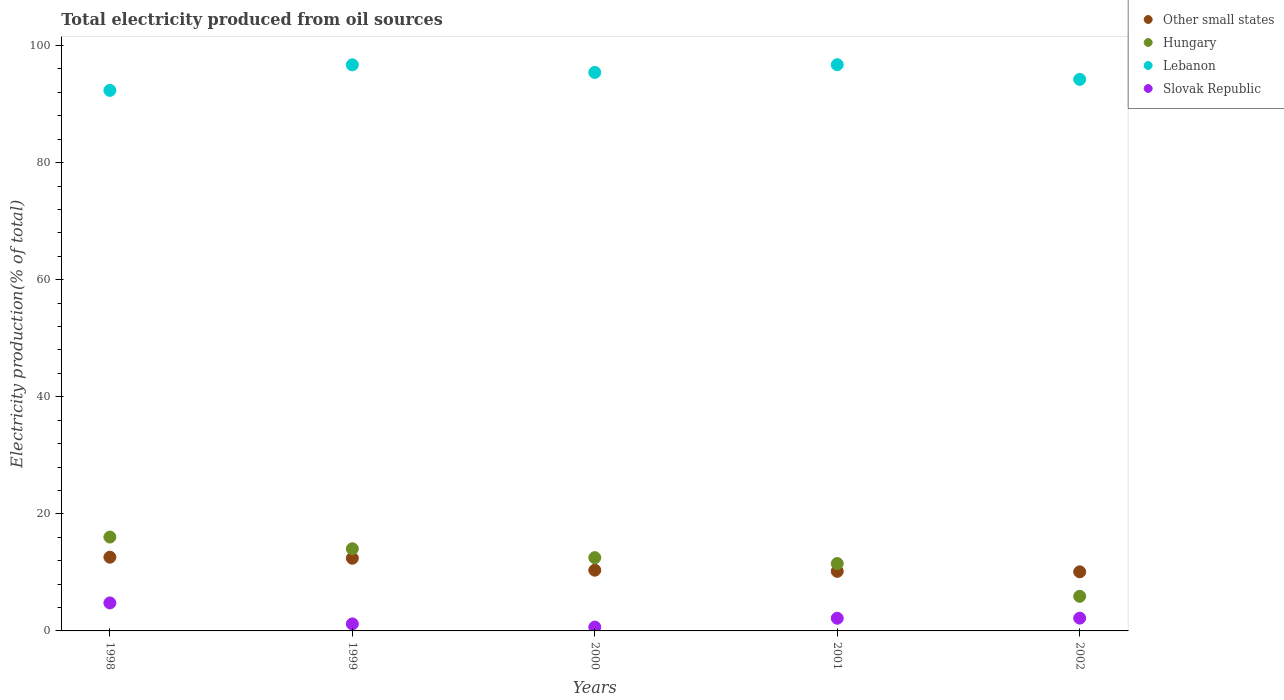Is the number of dotlines equal to the number of legend labels?
Provide a succinct answer. Yes. What is the total electricity produced in Lebanon in 2000?
Ensure brevity in your answer.  95.4. Across all years, what is the maximum total electricity produced in Other small states?
Your response must be concise. 12.6. Across all years, what is the minimum total electricity produced in Other small states?
Your answer should be compact. 10.09. In which year was the total electricity produced in Hungary minimum?
Your answer should be compact. 2002. What is the total total electricity produced in Other small states in the graph?
Offer a very short reply. 55.66. What is the difference between the total electricity produced in Hungary in 2000 and that in 2001?
Give a very brief answer. 1. What is the difference between the total electricity produced in Slovak Republic in 2002 and the total electricity produced in Other small states in 1999?
Your answer should be very brief. -10.23. What is the average total electricity produced in Lebanon per year?
Provide a succinct answer. 95.08. In the year 2002, what is the difference between the total electricity produced in Lebanon and total electricity produced in Slovak Republic?
Give a very brief answer. 92.03. In how many years, is the total electricity produced in Hungary greater than 16 %?
Give a very brief answer. 1. What is the ratio of the total electricity produced in Slovak Republic in 1998 to that in 2002?
Your answer should be very brief. 2.19. Is the total electricity produced in Slovak Republic in 1998 less than that in 1999?
Ensure brevity in your answer.  No. Is the difference between the total electricity produced in Lebanon in 1999 and 2000 greater than the difference between the total electricity produced in Slovak Republic in 1999 and 2000?
Offer a terse response. Yes. What is the difference between the highest and the second highest total electricity produced in Slovak Republic?
Ensure brevity in your answer.  2.6. What is the difference between the highest and the lowest total electricity produced in Other small states?
Provide a succinct answer. 2.5. In how many years, is the total electricity produced in Hungary greater than the average total electricity produced in Hungary taken over all years?
Provide a succinct answer. 3. Is it the case that in every year, the sum of the total electricity produced in Slovak Republic and total electricity produced in Hungary  is greater than the sum of total electricity produced in Other small states and total electricity produced in Lebanon?
Your answer should be compact. Yes. Is it the case that in every year, the sum of the total electricity produced in Lebanon and total electricity produced in Other small states  is greater than the total electricity produced in Slovak Republic?
Make the answer very short. Yes. Is the total electricity produced in Lebanon strictly greater than the total electricity produced in Slovak Republic over the years?
Provide a succinct answer. Yes. What is the difference between two consecutive major ticks on the Y-axis?
Offer a terse response. 20. Are the values on the major ticks of Y-axis written in scientific E-notation?
Your answer should be compact. No. Where does the legend appear in the graph?
Make the answer very short. Top right. What is the title of the graph?
Give a very brief answer. Total electricity produced from oil sources. Does "Cambodia" appear as one of the legend labels in the graph?
Give a very brief answer. No. What is the label or title of the X-axis?
Your response must be concise. Years. What is the label or title of the Y-axis?
Your answer should be compact. Electricity production(% of total). What is the Electricity production(% of total) of Other small states in 1998?
Offer a very short reply. 12.6. What is the Electricity production(% of total) of Hungary in 1998?
Your answer should be compact. 16.03. What is the Electricity production(% of total) in Lebanon in 1998?
Offer a very short reply. 92.34. What is the Electricity production(% of total) in Slovak Republic in 1998?
Offer a very short reply. 4.78. What is the Electricity production(% of total) of Other small states in 1999?
Your answer should be very brief. 12.42. What is the Electricity production(% of total) in Hungary in 1999?
Provide a short and direct response. 14.03. What is the Electricity production(% of total) of Lebanon in 1999?
Offer a terse response. 96.71. What is the Electricity production(% of total) of Slovak Republic in 1999?
Ensure brevity in your answer.  1.2. What is the Electricity production(% of total) of Other small states in 2000?
Ensure brevity in your answer.  10.37. What is the Electricity production(% of total) of Hungary in 2000?
Make the answer very short. 12.51. What is the Electricity production(% of total) of Lebanon in 2000?
Your answer should be compact. 95.4. What is the Electricity production(% of total) of Slovak Republic in 2000?
Give a very brief answer. 0.66. What is the Electricity production(% of total) of Other small states in 2001?
Provide a succinct answer. 10.18. What is the Electricity production(% of total) of Hungary in 2001?
Provide a short and direct response. 11.51. What is the Electricity production(% of total) of Lebanon in 2001?
Give a very brief answer. 96.72. What is the Electricity production(% of total) of Slovak Republic in 2001?
Ensure brevity in your answer.  2.17. What is the Electricity production(% of total) in Other small states in 2002?
Provide a succinct answer. 10.09. What is the Electricity production(% of total) in Hungary in 2002?
Provide a succinct answer. 5.91. What is the Electricity production(% of total) of Lebanon in 2002?
Give a very brief answer. 94.22. What is the Electricity production(% of total) in Slovak Republic in 2002?
Your answer should be compact. 2.19. Across all years, what is the maximum Electricity production(% of total) in Other small states?
Offer a terse response. 12.6. Across all years, what is the maximum Electricity production(% of total) in Hungary?
Your response must be concise. 16.03. Across all years, what is the maximum Electricity production(% of total) in Lebanon?
Your response must be concise. 96.72. Across all years, what is the maximum Electricity production(% of total) in Slovak Republic?
Provide a succinct answer. 4.78. Across all years, what is the minimum Electricity production(% of total) in Other small states?
Offer a terse response. 10.09. Across all years, what is the minimum Electricity production(% of total) of Hungary?
Keep it short and to the point. 5.91. Across all years, what is the minimum Electricity production(% of total) in Lebanon?
Make the answer very short. 92.34. Across all years, what is the minimum Electricity production(% of total) of Slovak Republic?
Your answer should be very brief. 0.66. What is the total Electricity production(% of total) of Other small states in the graph?
Make the answer very short. 55.66. What is the total Electricity production(% of total) of Hungary in the graph?
Your answer should be compact. 60. What is the total Electricity production(% of total) in Lebanon in the graph?
Offer a very short reply. 475.38. What is the total Electricity production(% of total) of Slovak Republic in the graph?
Provide a short and direct response. 10.99. What is the difference between the Electricity production(% of total) in Other small states in 1998 and that in 1999?
Give a very brief answer. 0.18. What is the difference between the Electricity production(% of total) of Hungary in 1998 and that in 1999?
Keep it short and to the point. 2. What is the difference between the Electricity production(% of total) in Lebanon in 1998 and that in 1999?
Offer a terse response. -4.37. What is the difference between the Electricity production(% of total) in Slovak Republic in 1998 and that in 1999?
Keep it short and to the point. 3.58. What is the difference between the Electricity production(% of total) in Other small states in 1998 and that in 2000?
Your answer should be very brief. 2.22. What is the difference between the Electricity production(% of total) in Hungary in 1998 and that in 2000?
Offer a very short reply. 3.52. What is the difference between the Electricity production(% of total) in Lebanon in 1998 and that in 2000?
Make the answer very short. -3.06. What is the difference between the Electricity production(% of total) of Slovak Republic in 1998 and that in 2000?
Keep it short and to the point. 4.13. What is the difference between the Electricity production(% of total) of Other small states in 1998 and that in 2001?
Your answer should be very brief. 2.42. What is the difference between the Electricity production(% of total) in Hungary in 1998 and that in 2001?
Your response must be concise. 4.52. What is the difference between the Electricity production(% of total) of Lebanon in 1998 and that in 2001?
Give a very brief answer. -4.39. What is the difference between the Electricity production(% of total) of Slovak Republic in 1998 and that in 2001?
Keep it short and to the point. 2.62. What is the difference between the Electricity production(% of total) in Other small states in 1998 and that in 2002?
Your answer should be very brief. 2.5. What is the difference between the Electricity production(% of total) of Hungary in 1998 and that in 2002?
Offer a very short reply. 10.12. What is the difference between the Electricity production(% of total) in Lebanon in 1998 and that in 2002?
Ensure brevity in your answer.  -1.88. What is the difference between the Electricity production(% of total) in Slovak Republic in 1998 and that in 2002?
Ensure brevity in your answer.  2.6. What is the difference between the Electricity production(% of total) in Other small states in 1999 and that in 2000?
Provide a succinct answer. 2.04. What is the difference between the Electricity production(% of total) of Hungary in 1999 and that in 2000?
Keep it short and to the point. 1.52. What is the difference between the Electricity production(% of total) of Lebanon in 1999 and that in 2000?
Ensure brevity in your answer.  1.31. What is the difference between the Electricity production(% of total) in Slovak Republic in 1999 and that in 2000?
Make the answer very short. 0.55. What is the difference between the Electricity production(% of total) of Other small states in 1999 and that in 2001?
Provide a short and direct response. 2.24. What is the difference between the Electricity production(% of total) of Hungary in 1999 and that in 2001?
Give a very brief answer. 2.52. What is the difference between the Electricity production(% of total) of Lebanon in 1999 and that in 2001?
Your answer should be very brief. -0.02. What is the difference between the Electricity production(% of total) of Slovak Republic in 1999 and that in 2001?
Give a very brief answer. -0.96. What is the difference between the Electricity production(% of total) of Other small states in 1999 and that in 2002?
Give a very brief answer. 2.32. What is the difference between the Electricity production(% of total) in Hungary in 1999 and that in 2002?
Make the answer very short. 8.12. What is the difference between the Electricity production(% of total) in Lebanon in 1999 and that in 2002?
Provide a succinct answer. 2.49. What is the difference between the Electricity production(% of total) of Slovak Republic in 1999 and that in 2002?
Make the answer very short. -0.98. What is the difference between the Electricity production(% of total) in Other small states in 2000 and that in 2001?
Provide a succinct answer. 0.2. What is the difference between the Electricity production(% of total) in Lebanon in 2000 and that in 2001?
Give a very brief answer. -1.33. What is the difference between the Electricity production(% of total) in Slovak Republic in 2000 and that in 2001?
Keep it short and to the point. -1.51. What is the difference between the Electricity production(% of total) in Other small states in 2000 and that in 2002?
Your response must be concise. 0.28. What is the difference between the Electricity production(% of total) of Hungary in 2000 and that in 2002?
Provide a succinct answer. 6.6. What is the difference between the Electricity production(% of total) of Lebanon in 2000 and that in 2002?
Provide a short and direct response. 1.18. What is the difference between the Electricity production(% of total) of Slovak Republic in 2000 and that in 2002?
Your response must be concise. -1.53. What is the difference between the Electricity production(% of total) in Other small states in 2001 and that in 2002?
Your response must be concise. 0.08. What is the difference between the Electricity production(% of total) of Hungary in 2001 and that in 2002?
Ensure brevity in your answer.  5.6. What is the difference between the Electricity production(% of total) of Lebanon in 2001 and that in 2002?
Offer a terse response. 2.51. What is the difference between the Electricity production(% of total) in Slovak Republic in 2001 and that in 2002?
Provide a succinct answer. -0.02. What is the difference between the Electricity production(% of total) of Other small states in 1998 and the Electricity production(% of total) of Hungary in 1999?
Keep it short and to the point. -1.44. What is the difference between the Electricity production(% of total) of Other small states in 1998 and the Electricity production(% of total) of Lebanon in 1999?
Provide a succinct answer. -84.11. What is the difference between the Electricity production(% of total) of Other small states in 1998 and the Electricity production(% of total) of Slovak Republic in 1999?
Your answer should be compact. 11.39. What is the difference between the Electricity production(% of total) in Hungary in 1998 and the Electricity production(% of total) in Lebanon in 1999?
Provide a short and direct response. -80.67. What is the difference between the Electricity production(% of total) of Hungary in 1998 and the Electricity production(% of total) of Slovak Republic in 1999?
Your answer should be very brief. 14.83. What is the difference between the Electricity production(% of total) of Lebanon in 1998 and the Electricity production(% of total) of Slovak Republic in 1999?
Ensure brevity in your answer.  91.13. What is the difference between the Electricity production(% of total) in Other small states in 1998 and the Electricity production(% of total) in Hungary in 2000?
Offer a very short reply. 0.08. What is the difference between the Electricity production(% of total) of Other small states in 1998 and the Electricity production(% of total) of Lebanon in 2000?
Your response must be concise. -82.8. What is the difference between the Electricity production(% of total) in Other small states in 1998 and the Electricity production(% of total) in Slovak Republic in 2000?
Your answer should be very brief. 11.94. What is the difference between the Electricity production(% of total) in Hungary in 1998 and the Electricity production(% of total) in Lebanon in 2000?
Provide a short and direct response. -79.36. What is the difference between the Electricity production(% of total) of Hungary in 1998 and the Electricity production(% of total) of Slovak Republic in 2000?
Ensure brevity in your answer.  15.38. What is the difference between the Electricity production(% of total) in Lebanon in 1998 and the Electricity production(% of total) in Slovak Republic in 2000?
Your answer should be compact. 91.68. What is the difference between the Electricity production(% of total) in Other small states in 1998 and the Electricity production(% of total) in Hungary in 2001?
Keep it short and to the point. 1.08. What is the difference between the Electricity production(% of total) of Other small states in 1998 and the Electricity production(% of total) of Lebanon in 2001?
Keep it short and to the point. -84.13. What is the difference between the Electricity production(% of total) of Other small states in 1998 and the Electricity production(% of total) of Slovak Republic in 2001?
Keep it short and to the point. 10.43. What is the difference between the Electricity production(% of total) in Hungary in 1998 and the Electricity production(% of total) in Lebanon in 2001?
Keep it short and to the point. -80.69. What is the difference between the Electricity production(% of total) of Hungary in 1998 and the Electricity production(% of total) of Slovak Republic in 2001?
Give a very brief answer. 13.87. What is the difference between the Electricity production(% of total) in Lebanon in 1998 and the Electricity production(% of total) in Slovak Republic in 2001?
Your response must be concise. 90.17. What is the difference between the Electricity production(% of total) in Other small states in 1998 and the Electricity production(% of total) in Hungary in 2002?
Keep it short and to the point. 6.69. What is the difference between the Electricity production(% of total) in Other small states in 1998 and the Electricity production(% of total) in Lebanon in 2002?
Offer a very short reply. -81.62. What is the difference between the Electricity production(% of total) of Other small states in 1998 and the Electricity production(% of total) of Slovak Republic in 2002?
Offer a very short reply. 10.41. What is the difference between the Electricity production(% of total) of Hungary in 1998 and the Electricity production(% of total) of Lebanon in 2002?
Offer a terse response. -78.18. What is the difference between the Electricity production(% of total) of Hungary in 1998 and the Electricity production(% of total) of Slovak Republic in 2002?
Your response must be concise. 13.85. What is the difference between the Electricity production(% of total) of Lebanon in 1998 and the Electricity production(% of total) of Slovak Republic in 2002?
Your answer should be very brief. 90.15. What is the difference between the Electricity production(% of total) of Other small states in 1999 and the Electricity production(% of total) of Hungary in 2000?
Give a very brief answer. -0.1. What is the difference between the Electricity production(% of total) in Other small states in 1999 and the Electricity production(% of total) in Lebanon in 2000?
Your answer should be compact. -82.98. What is the difference between the Electricity production(% of total) in Other small states in 1999 and the Electricity production(% of total) in Slovak Republic in 2000?
Your response must be concise. 11.76. What is the difference between the Electricity production(% of total) in Hungary in 1999 and the Electricity production(% of total) in Lebanon in 2000?
Your response must be concise. -81.37. What is the difference between the Electricity production(% of total) of Hungary in 1999 and the Electricity production(% of total) of Slovak Republic in 2000?
Provide a short and direct response. 13.38. What is the difference between the Electricity production(% of total) in Lebanon in 1999 and the Electricity production(% of total) in Slovak Republic in 2000?
Provide a short and direct response. 96.05. What is the difference between the Electricity production(% of total) of Other small states in 1999 and the Electricity production(% of total) of Hungary in 2001?
Provide a succinct answer. 0.91. What is the difference between the Electricity production(% of total) of Other small states in 1999 and the Electricity production(% of total) of Lebanon in 2001?
Your response must be concise. -84.31. What is the difference between the Electricity production(% of total) in Other small states in 1999 and the Electricity production(% of total) in Slovak Republic in 2001?
Make the answer very short. 10.25. What is the difference between the Electricity production(% of total) of Hungary in 1999 and the Electricity production(% of total) of Lebanon in 2001?
Your answer should be compact. -82.69. What is the difference between the Electricity production(% of total) in Hungary in 1999 and the Electricity production(% of total) in Slovak Republic in 2001?
Keep it short and to the point. 11.87. What is the difference between the Electricity production(% of total) of Lebanon in 1999 and the Electricity production(% of total) of Slovak Republic in 2001?
Your answer should be very brief. 94.54. What is the difference between the Electricity production(% of total) of Other small states in 1999 and the Electricity production(% of total) of Hungary in 2002?
Keep it short and to the point. 6.51. What is the difference between the Electricity production(% of total) of Other small states in 1999 and the Electricity production(% of total) of Lebanon in 2002?
Your answer should be very brief. -81.8. What is the difference between the Electricity production(% of total) of Other small states in 1999 and the Electricity production(% of total) of Slovak Republic in 2002?
Give a very brief answer. 10.23. What is the difference between the Electricity production(% of total) of Hungary in 1999 and the Electricity production(% of total) of Lebanon in 2002?
Provide a succinct answer. -80.18. What is the difference between the Electricity production(% of total) in Hungary in 1999 and the Electricity production(% of total) in Slovak Republic in 2002?
Give a very brief answer. 11.85. What is the difference between the Electricity production(% of total) in Lebanon in 1999 and the Electricity production(% of total) in Slovak Republic in 2002?
Your answer should be very brief. 94.52. What is the difference between the Electricity production(% of total) in Other small states in 2000 and the Electricity production(% of total) in Hungary in 2001?
Offer a very short reply. -1.14. What is the difference between the Electricity production(% of total) of Other small states in 2000 and the Electricity production(% of total) of Lebanon in 2001?
Give a very brief answer. -86.35. What is the difference between the Electricity production(% of total) in Other small states in 2000 and the Electricity production(% of total) in Slovak Republic in 2001?
Offer a terse response. 8.21. What is the difference between the Electricity production(% of total) of Hungary in 2000 and the Electricity production(% of total) of Lebanon in 2001?
Your answer should be compact. -84.21. What is the difference between the Electricity production(% of total) in Hungary in 2000 and the Electricity production(% of total) in Slovak Republic in 2001?
Offer a terse response. 10.35. What is the difference between the Electricity production(% of total) of Lebanon in 2000 and the Electricity production(% of total) of Slovak Republic in 2001?
Ensure brevity in your answer.  93.23. What is the difference between the Electricity production(% of total) of Other small states in 2000 and the Electricity production(% of total) of Hungary in 2002?
Provide a succinct answer. 4.46. What is the difference between the Electricity production(% of total) of Other small states in 2000 and the Electricity production(% of total) of Lebanon in 2002?
Keep it short and to the point. -83.84. What is the difference between the Electricity production(% of total) in Other small states in 2000 and the Electricity production(% of total) in Slovak Republic in 2002?
Your answer should be very brief. 8.19. What is the difference between the Electricity production(% of total) in Hungary in 2000 and the Electricity production(% of total) in Lebanon in 2002?
Keep it short and to the point. -81.7. What is the difference between the Electricity production(% of total) in Hungary in 2000 and the Electricity production(% of total) in Slovak Republic in 2002?
Ensure brevity in your answer.  10.33. What is the difference between the Electricity production(% of total) of Lebanon in 2000 and the Electricity production(% of total) of Slovak Republic in 2002?
Your answer should be compact. 93.21. What is the difference between the Electricity production(% of total) of Other small states in 2001 and the Electricity production(% of total) of Hungary in 2002?
Provide a succinct answer. 4.27. What is the difference between the Electricity production(% of total) of Other small states in 2001 and the Electricity production(% of total) of Lebanon in 2002?
Provide a short and direct response. -84.04. What is the difference between the Electricity production(% of total) of Other small states in 2001 and the Electricity production(% of total) of Slovak Republic in 2002?
Give a very brief answer. 7.99. What is the difference between the Electricity production(% of total) in Hungary in 2001 and the Electricity production(% of total) in Lebanon in 2002?
Keep it short and to the point. -82.7. What is the difference between the Electricity production(% of total) in Hungary in 2001 and the Electricity production(% of total) in Slovak Republic in 2002?
Provide a short and direct response. 9.33. What is the difference between the Electricity production(% of total) of Lebanon in 2001 and the Electricity production(% of total) of Slovak Republic in 2002?
Give a very brief answer. 94.54. What is the average Electricity production(% of total) of Other small states per year?
Offer a very short reply. 11.13. What is the average Electricity production(% of total) in Hungary per year?
Ensure brevity in your answer.  12. What is the average Electricity production(% of total) in Lebanon per year?
Ensure brevity in your answer.  95.08. What is the average Electricity production(% of total) in Slovak Republic per year?
Your response must be concise. 2.2. In the year 1998, what is the difference between the Electricity production(% of total) of Other small states and Electricity production(% of total) of Hungary?
Your response must be concise. -3.44. In the year 1998, what is the difference between the Electricity production(% of total) of Other small states and Electricity production(% of total) of Lebanon?
Ensure brevity in your answer.  -79.74. In the year 1998, what is the difference between the Electricity production(% of total) in Other small states and Electricity production(% of total) in Slovak Republic?
Ensure brevity in your answer.  7.81. In the year 1998, what is the difference between the Electricity production(% of total) of Hungary and Electricity production(% of total) of Lebanon?
Provide a short and direct response. -76.3. In the year 1998, what is the difference between the Electricity production(% of total) in Hungary and Electricity production(% of total) in Slovak Republic?
Your response must be concise. 11.25. In the year 1998, what is the difference between the Electricity production(% of total) of Lebanon and Electricity production(% of total) of Slovak Republic?
Keep it short and to the point. 87.55. In the year 1999, what is the difference between the Electricity production(% of total) in Other small states and Electricity production(% of total) in Hungary?
Provide a succinct answer. -1.62. In the year 1999, what is the difference between the Electricity production(% of total) of Other small states and Electricity production(% of total) of Lebanon?
Your response must be concise. -84.29. In the year 1999, what is the difference between the Electricity production(% of total) in Other small states and Electricity production(% of total) in Slovak Republic?
Provide a succinct answer. 11.21. In the year 1999, what is the difference between the Electricity production(% of total) of Hungary and Electricity production(% of total) of Lebanon?
Make the answer very short. -82.67. In the year 1999, what is the difference between the Electricity production(% of total) of Hungary and Electricity production(% of total) of Slovak Republic?
Provide a short and direct response. 12.83. In the year 1999, what is the difference between the Electricity production(% of total) in Lebanon and Electricity production(% of total) in Slovak Republic?
Provide a short and direct response. 95.5. In the year 2000, what is the difference between the Electricity production(% of total) in Other small states and Electricity production(% of total) in Hungary?
Ensure brevity in your answer.  -2.14. In the year 2000, what is the difference between the Electricity production(% of total) of Other small states and Electricity production(% of total) of Lebanon?
Your response must be concise. -85.02. In the year 2000, what is the difference between the Electricity production(% of total) in Other small states and Electricity production(% of total) in Slovak Republic?
Give a very brief answer. 9.72. In the year 2000, what is the difference between the Electricity production(% of total) in Hungary and Electricity production(% of total) in Lebanon?
Your response must be concise. -82.88. In the year 2000, what is the difference between the Electricity production(% of total) of Hungary and Electricity production(% of total) of Slovak Republic?
Provide a succinct answer. 11.86. In the year 2000, what is the difference between the Electricity production(% of total) in Lebanon and Electricity production(% of total) in Slovak Republic?
Provide a succinct answer. 94.74. In the year 2001, what is the difference between the Electricity production(% of total) in Other small states and Electricity production(% of total) in Hungary?
Make the answer very short. -1.34. In the year 2001, what is the difference between the Electricity production(% of total) in Other small states and Electricity production(% of total) in Lebanon?
Keep it short and to the point. -86.55. In the year 2001, what is the difference between the Electricity production(% of total) of Other small states and Electricity production(% of total) of Slovak Republic?
Offer a very short reply. 8.01. In the year 2001, what is the difference between the Electricity production(% of total) in Hungary and Electricity production(% of total) in Lebanon?
Your response must be concise. -85.21. In the year 2001, what is the difference between the Electricity production(% of total) in Hungary and Electricity production(% of total) in Slovak Republic?
Make the answer very short. 9.35. In the year 2001, what is the difference between the Electricity production(% of total) in Lebanon and Electricity production(% of total) in Slovak Republic?
Your answer should be compact. 94.56. In the year 2002, what is the difference between the Electricity production(% of total) of Other small states and Electricity production(% of total) of Hungary?
Your response must be concise. 4.18. In the year 2002, what is the difference between the Electricity production(% of total) of Other small states and Electricity production(% of total) of Lebanon?
Your answer should be compact. -84.12. In the year 2002, what is the difference between the Electricity production(% of total) in Other small states and Electricity production(% of total) in Slovak Republic?
Offer a terse response. 7.91. In the year 2002, what is the difference between the Electricity production(% of total) of Hungary and Electricity production(% of total) of Lebanon?
Your answer should be compact. -88.31. In the year 2002, what is the difference between the Electricity production(% of total) of Hungary and Electricity production(% of total) of Slovak Republic?
Ensure brevity in your answer.  3.72. In the year 2002, what is the difference between the Electricity production(% of total) in Lebanon and Electricity production(% of total) in Slovak Republic?
Your answer should be compact. 92.03. What is the ratio of the Electricity production(% of total) of Other small states in 1998 to that in 1999?
Your answer should be compact. 1.01. What is the ratio of the Electricity production(% of total) of Hungary in 1998 to that in 1999?
Your answer should be compact. 1.14. What is the ratio of the Electricity production(% of total) in Lebanon in 1998 to that in 1999?
Your response must be concise. 0.95. What is the ratio of the Electricity production(% of total) in Slovak Republic in 1998 to that in 1999?
Offer a very short reply. 3.98. What is the ratio of the Electricity production(% of total) of Other small states in 1998 to that in 2000?
Provide a succinct answer. 1.21. What is the ratio of the Electricity production(% of total) in Hungary in 1998 to that in 2000?
Provide a short and direct response. 1.28. What is the ratio of the Electricity production(% of total) in Lebanon in 1998 to that in 2000?
Ensure brevity in your answer.  0.97. What is the ratio of the Electricity production(% of total) in Slovak Republic in 1998 to that in 2000?
Give a very brief answer. 7.29. What is the ratio of the Electricity production(% of total) in Other small states in 1998 to that in 2001?
Give a very brief answer. 1.24. What is the ratio of the Electricity production(% of total) in Hungary in 1998 to that in 2001?
Provide a succinct answer. 1.39. What is the ratio of the Electricity production(% of total) in Lebanon in 1998 to that in 2001?
Give a very brief answer. 0.95. What is the ratio of the Electricity production(% of total) in Slovak Republic in 1998 to that in 2001?
Your response must be concise. 2.21. What is the ratio of the Electricity production(% of total) of Other small states in 1998 to that in 2002?
Your answer should be compact. 1.25. What is the ratio of the Electricity production(% of total) of Hungary in 1998 to that in 2002?
Make the answer very short. 2.71. What is the ratio of the Electricity production(% of total) in Lebanon in 1998 to that in 2002?
Your response must be concise. 0.98. What is the ratio of the Electricity production(% of total) of Slovak Republic in 1998 to that in 2002?
Keep it short and to the point. 2.19. What is the ratio of the Electricity production(% of total) of Other small states in 1999 to that in 2000?
Your answer should be compact. 1.2. What is the ratio of the Electricity production(% of total) in Hungary in 1999 to that in 2000?
Make the answer very short. 1.12. What is the ratio of the Electricity production(% of total) of Lebanon in 1999 to that in 2000?
Offer a very short reply. 1.01. What is the ratio of the Electricity production(% of total) of Slovak Republic in 1999 to that in 2000?
Your response must be concise. 1.83. What is the ratio of the Electricity production(% of total) of Other small states in 1999 to that in 2001?
Your answer should be very brief. 1.22. What is the ratio of the Electricity production(% of total) of Hungary in 1999 to that in 2001?
Offer a very short reply. 1.22. What is the ratio of the Electricity production(% of total) of Slovak Republic in 1999 to that in 2001?
Your response must be concise. 0.56. What is the ratio of the Electricity production(% of total) of Other small states in 1999 to that in 2002?
Keep it short and to the point. 1.23. What is the ratio of the Electricity production(% of total) of Hungary in 1999 to that in 2002?
Provide a short and direct response. 2.37. What is the ratio of the Electricity production(% of total) of Lebanon in 1999 to that in 2002?
Offer a very short reply. 1.03. What is the ratio of the Electricity production(% of total) of Slovak Republic in 1999 to that in 2002?
Your answer should be compact. 0.55. What is the ratio of the Electricity production(% of total) in Other small states in 2000 to that in 2001?
Your answer should be compact. 1.02. What is the ratio of the Electricity production(% of total) of Hungary in 2000 to that in 2001?
Offer a very short reply. 1.09. What is the ratio of the Electricity production(% of total) in Lebanon in 2000 to that in 2001?
Provide a short and direct response. 0.99. What is the ratio of the Electricity production(% of total) of Slovak Republic in 2000 to that in 2001?
Provide a short and direct response. 0.3. What is the ratio of the Electricity production(% of total) of Other small states in 2000 to that in 2002?
Ensure brevity in your answer.  1.03. What is the ratio of the Electricity production(% of total) of Hungary in 2000 to that in 2002?
Your answer should be very brief. 2.12. What is the ratio of the Electricity production(% of total) of Lebanon in 2000 to that in 2002?
Your answer should be compact. 1.01. What is the ratio of the Electricity production(% of total) in Slovak Republic in 2000 to that in 2002?
Your response must be concise. 0.3. What is the ratio of the Electricity production(% of total) of Hungary in 2001 to that in 2002?
Provide a short and direct response. 1.95. What is the ratio of the Electricity production(% of total) in Lebanon in 2001 to that in 2002?
Provide a succinct answer. 1.03. What is the ratio of the Electricity production(% of total) in Slovak Republic in 2001 to that in 2002?
Your response must be concise. 0.99. What is the difference between the highest and the second highest Electricity production(% of total) in Other small states?
Your response must be concise. 0.18. What is the difference between the highest and the second highest Electricity production(% of total) in Hungary?
Make the answer very short. 2. What is the difference between the highest and the second highest Electricity production(% of total) of Lebanon?
Provide a short and direct response. 0.02. What is the difference between the highest and the second highest Electricity production(% of total) of Slovak Republic?
Offer a terse response. 2.6. What is the difference between the highest and the lowest Electricity production(% of total) of Other small states?
Offer a terse response. 2.5. What is the difference between the highest and the lowest Electricity production(% of total) of Hungary?
Offer a terse response. 10.12. What is the difference between the highest and the lowest Electricity production(% of total) in Lebanon?
Ensure brevity in your answer.  4.39. What is the difference between the highest and the lowest Electricity production(% of total) in Slovak Republic?
Provide a short and direct response. 4.13. 